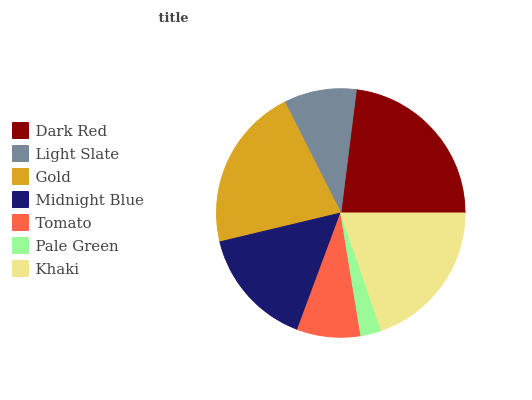Is Pale Green the minimum?
Answer yes or no. Yes. Is Dark Red the maximum?
Answer yes or no. Yes. Is Light Slate the minimum?
Answer yes or no. No. Is Light Slate the maximum?
Answer yes or no. No. Is Dark Red greater than Light Slate?
Answer yes or no. Yes. Is Light Slate less than Dark Red?
Answer yes or no. Yes. Is Light Slate greater than Dark Red?
Answer yes or no. No. Is Dark Red less than Light Slate?
Answer yes or no. No. Is Midnight Blue the high median?
Answer yes or no. Yes. Is Midnight Blue the low median?
Answer yes or no. Yes. Is Tomato the high median?
Answer yes or no. No. Is Tomato the low median?
Answer yes or no. No. 